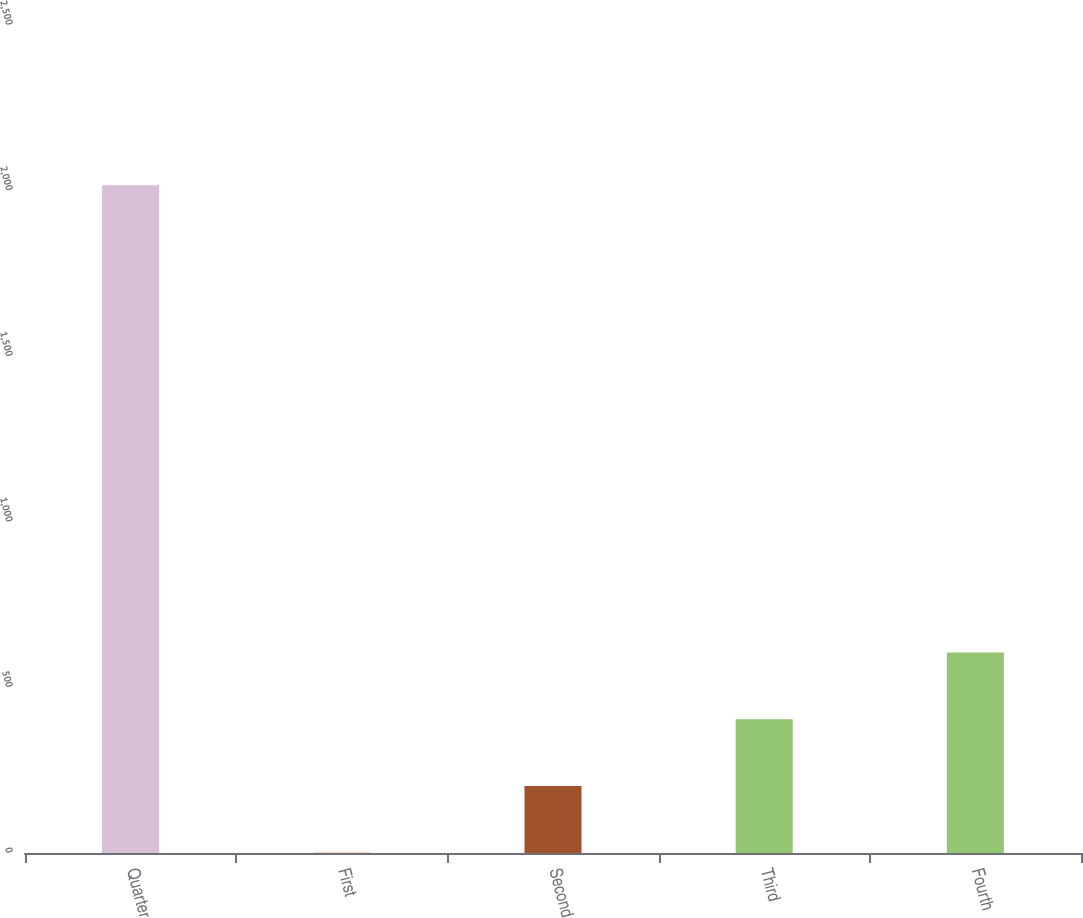<chart> <loc_0><loc_0><loc_500><loc_500><bar_chart><fcel>Quarter<fcel>First<fcel>Second<fcel>Third<fcel>Fourth<nl><fcel>2016<fcel>0.56<fcel>202.1<fcel>403.64<fcel>605.18<nl></chart> 